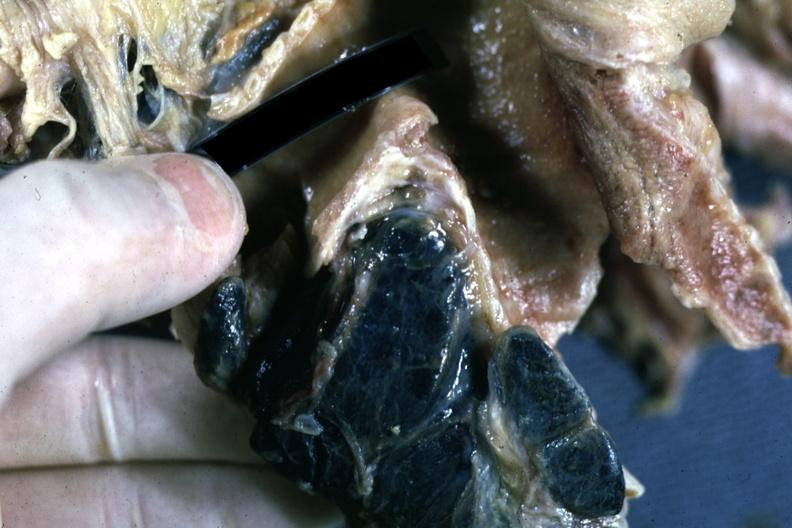what is present?
Answer the question using a single word or phrase. Lymph node 